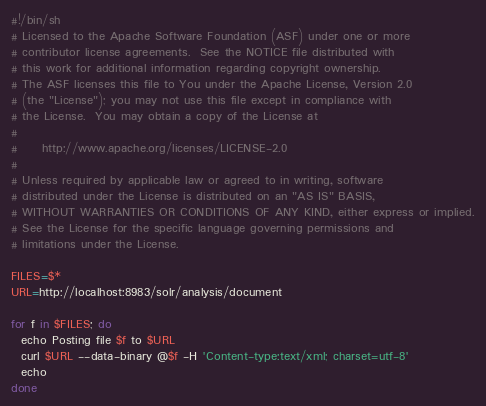<code> <loc_0><loc_0><loc_500><loc_500><_Bash_>#!/bin/sh
# Licensed to the Apache Software Foundation (ASF) under one or more
# contributor license agreements.  See the NOTICE file distributed with
# this work for additional information regarding copyright ownership.
# The ASF licenses this file to You under the Apache License, Version 2.0
# (the "License"); you may not use this file except in compliance with
# the License.  You may obtain a copy of the License at
#
#     http://www.apache.org/licenses/LICENSE-2.0
#
# Unless required by applicable law or agreed to in writing, software
# distributed under the License is distributed on an "AS IS" BASIS,
# WITHOUT WARRANTIES OR CONDITIONS OF ANY KIND, either express or implied.
# See the License for the specific language governing permissions and
# limitations under the License.

FILES=$*
URL=http://localhost:8983/solr/analysis/document

for f in $FILES; do
  echo Posting file $f to $URL
  curl $URL --data-binary @$f -H 'Content-type:text/xml; charset=utf-8' 
  echo
done
</code> 